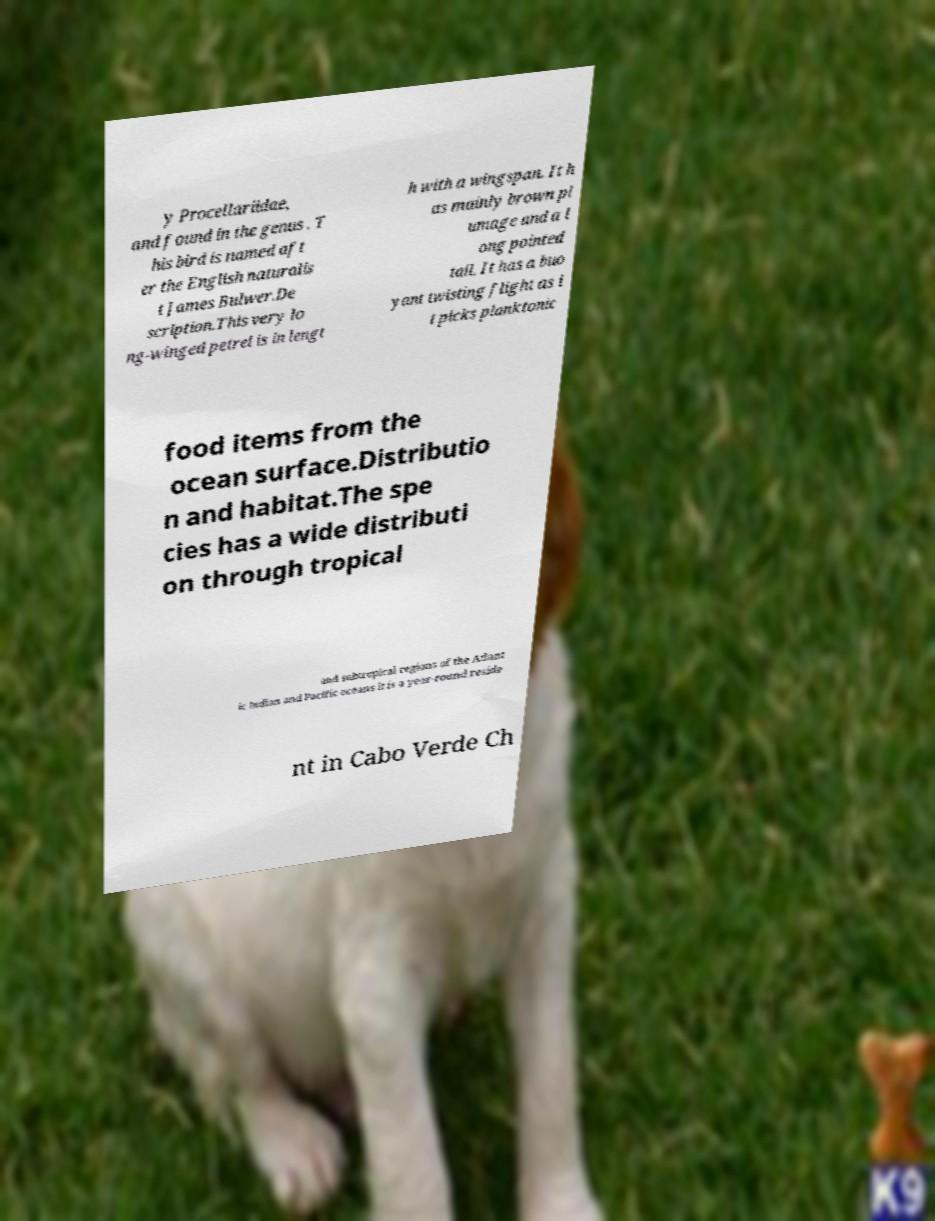What messages or text are displayed in this image? I need them in a readable, typed format. y Procellariidae, and found in the genus . T his bird is named aft er the English naturalis t James Bulwer.De scription.This very lo ng-winged petrel is in lengt h with a wingspan. It h as mainly brown pl umage and a l ong pointed tail. It has a buo yant twisting flight as i t picks planktonic food items from the ocean surface.Distributio n and habitat.The spe cies has a wide distributi on through tropical and subtropical regions of the Atlant ic Indian and Pacific oceans it is a year-round reside nt in Cabo Verde Ch 